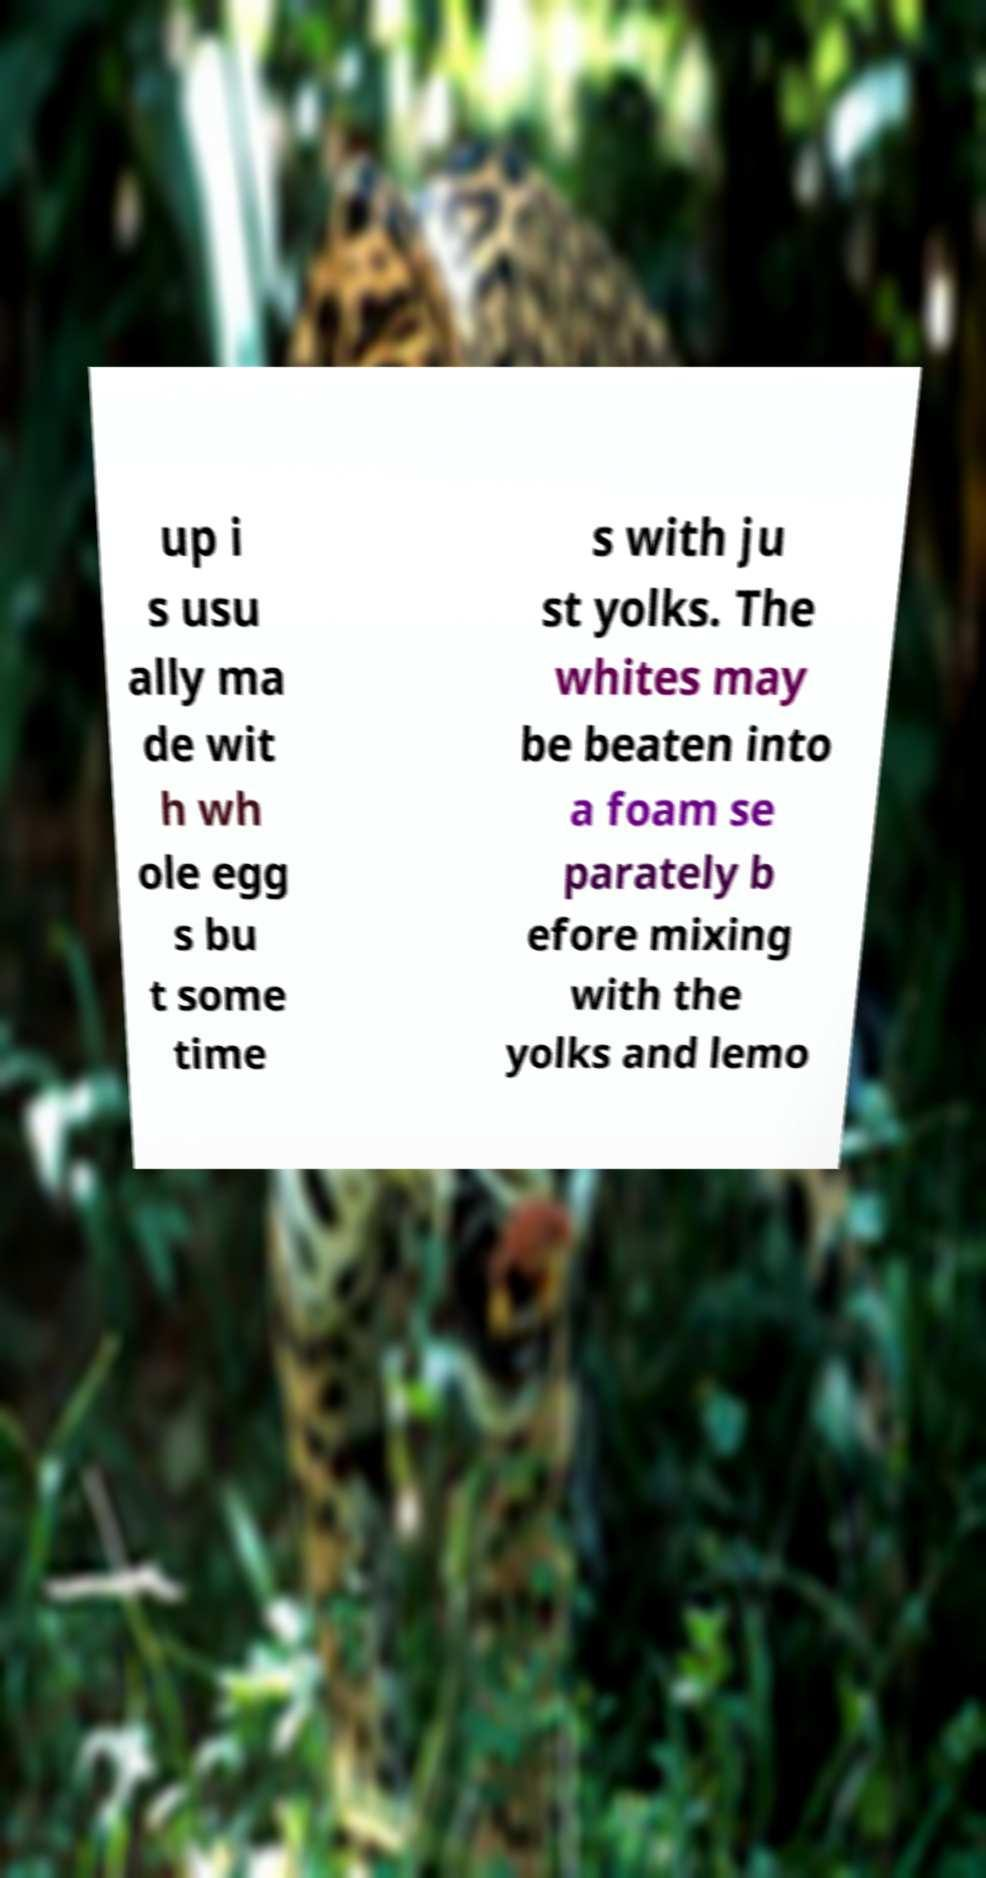Could you assist in decoding the text presented in this image and type it out clearly? up i s usu ally ma de wit h wh ole egg s bu t some time s with ju st yolks. The whites may be beaten into a foam se parately b efore mixing with the yolks and lemo 